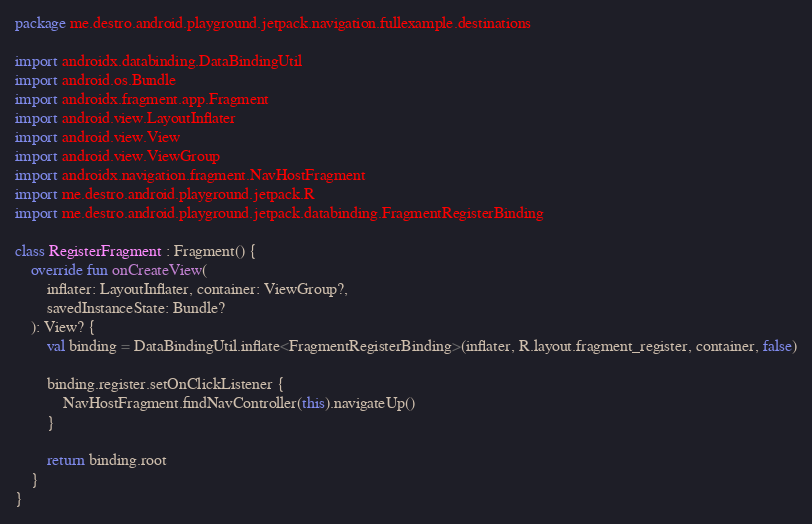<code> <loc_0><loc_0><loc_500><loc_500><_Kotlin_>package me.destro.android.playground.jetpack.navigation.fullexample.destinations

import androidx.databinding.DataBindingUtil
import android.os.Bundle
import androidx.fragment.app.Fragment
import android.view.LayoutInflater
import android.view.View
import android.view.ViewGroup
import androidx.navigation.fragment.NavHostFragment
import me.destro.android.playground.jetpack.R
import me.destro.android.playground.jetpack.databinding.FragmentRegisterBinding

class RegisterFragment : Fragment() {
    override fun onCreateView(
        inflater: LayoutInflater, container: ViewGroup?,
        savedInstanceState: Bundle?
    ): View? {
        val binding = DataBindingUtil.inflate<FragmentRegisterBinding>(inflater, R.layout.fragment_register, container, false)

        binding.register.setOnClickListener {
            NavHostFragment.findNavController(this).navigateUp()
        }

        return binding.root
    }
}
</code> 